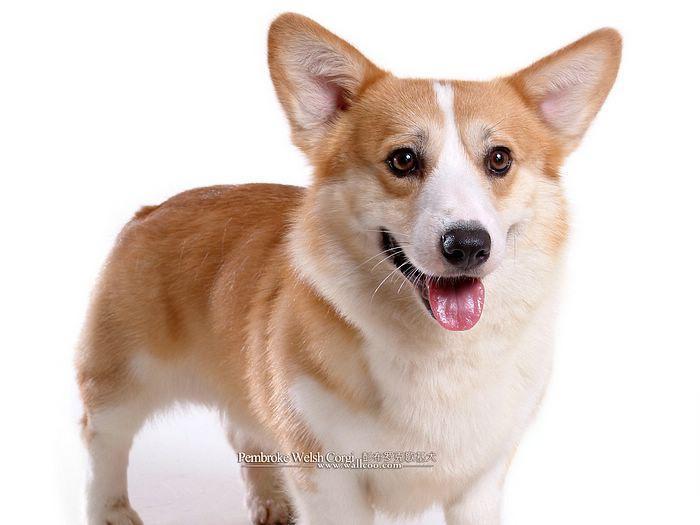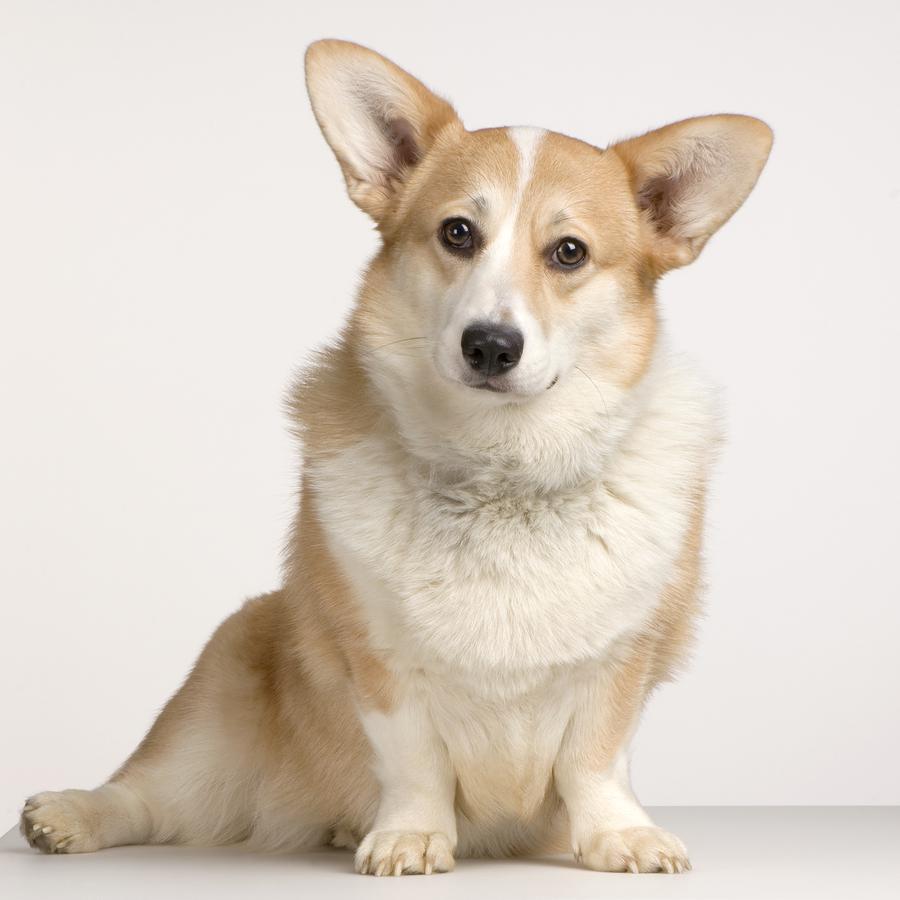The first image is the image on the left, the second image is the image on the right. Evaluate the accuracy of this statement regarding the images: "One dog is sitting and the other is laying flat with paws forward.". Is it true? Answer yes or no. No. 